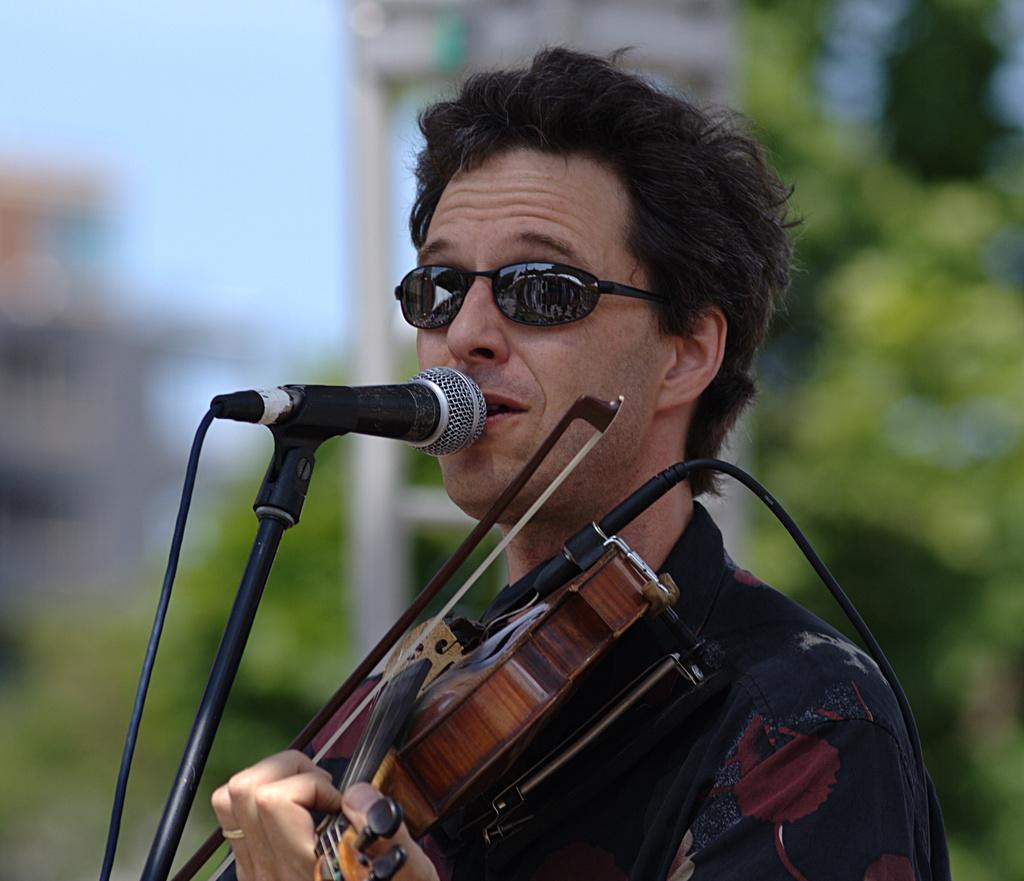What is the main subject of the image? There is a person in the image. What is the person wearing? The person is wearing a black color shirt. What accessory is the person wearing? The person is wearing goggles. What activity is the person engaged in? The person is playing a violin. What object is present in front of the person? There is a microphone in front of the person. What type of popcorn is being served in the image? There is no popcorn present in the image. Can you read the note that the person is holding in the image? There is no note visible in the image. 